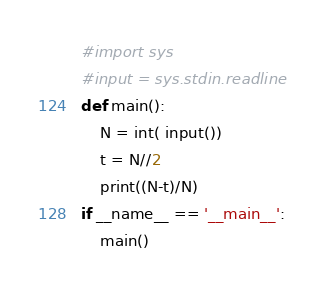<code> <loc_0><loc_0><loc_500><loc_500><_Python_>#import sys
#input = sys.stdin.readline
def main():
    N = int( input())
    t = N//2
    print((N-t)/N)
if __name__ == '__main__':
    main()</code> 